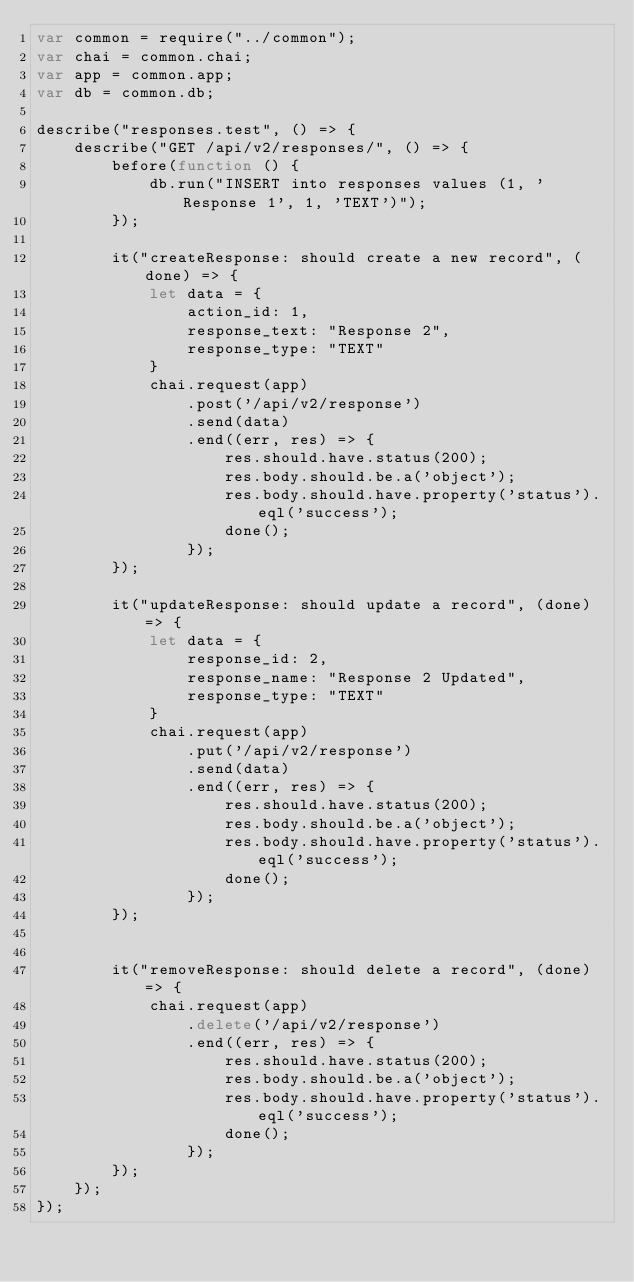<code> <loc_0><loc_0><loc_500><loc_500><_JavaScript_>var common = require("../common");
var chai = common.chai;
var app = common.app;
var db = common.db;

describe("responses.test", () => {
    describe("GET /api/v2/responses/", () => {
        before(function () {
            db.run("INSERT into responses values (1, 'Response 1', 1, 'TEXT')");
        });

        it("createResponse: should create a new record", (done) => {
            let data = {
                action_id: 1,
                response_text: "Response 2",
                response_type: "TEXT"
            }
            chai.request(app)
                .post('/api/v2/response')
                .send(data)
                .end((err, res) => {
                    res.should.have.status(200);
                    res.body.should.be.a('object');
                    res.body.should.have.property('status').eql('success');
                    done();
                });
        });

        it("updateResponse: should update a record", (done) => {
            let data = {
                response_id: 2,
                response_name: "Response 2 Updated",
                response_type: "TEXT"
            }
            chai.request(app)
                .put('/api/v2/response')
                .send(data)
                .end((err, res) => {
                    res.should.have.status(200);
                    res.body.should.be.a('object');
                    res.body.should.have.property('status').eql('success');
                    done();
                });
        });


        it("removeResponse: should delete a record", (done) => {
            chai.request(app)
                .delete('/api/v2/response')
                .end((err, res) => {
                    res.should.have.status(200);
                    res.body.should.be.a('object');
                    res.body.should.have.property('status').eql('success');
                    done();
                });
        });
    });
});</code> 